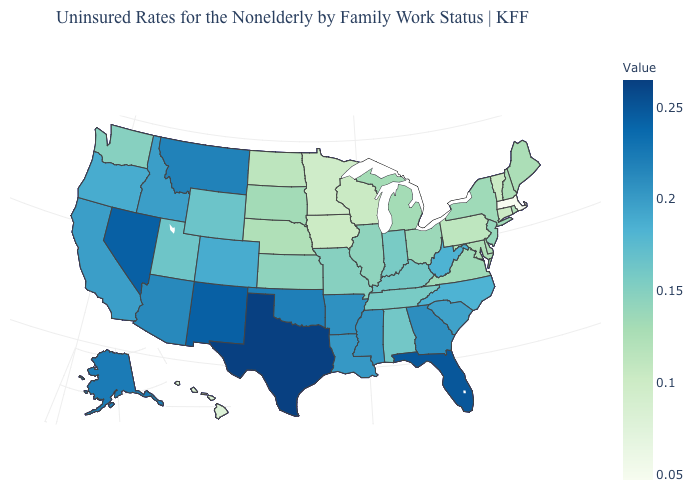Among the states that border Massachusetts , does New York have the highest value?
Be succinct. Yes. Which states hav the highest value in the Northeast?
Short answer required. New Jersey. 